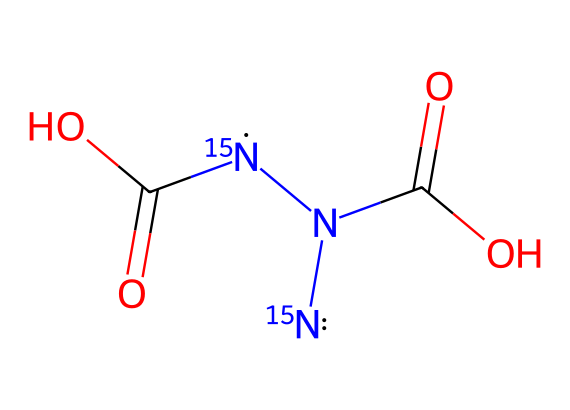How many nitrogen atoms are present in this compound? The SMILES representation indicates the presence of two [15N] nitrogen atoms, which are specifically labeled with the isotope nitrogen-15.
Answer: two What functional groups are present in this chemical structure? Analyzing the SMILES representation reveals two carboxylic acid groups (C(=O)O) attached to the central carbon and the nitrogen atoms.
Answer: carboxylic acid What is the total number of oxygen atoms in the structure? By examining the chemical representation, there are two oxygen atoms from each of the two carboxylic acid groups, leading to a total of four oxygen atoms in the compound.
Answer: four What type of nitrogen isotope is represented in this structure? The representation shows [15N], indicating that the nitrogen in this molecular structure is the nitrogen-15 isotope, which differs from the more common nitrogen-14.
Answer: nitrogen-15 How does the presence of nitrogen-15 affect the compound's use in food preservation packaging? Nitrogen-15, being an isotope, can provide useful tracking features in studies related to the compound's interaction with food products, potentially increasing the efficiency of its application in preserving food.
Answer: tracking What is the molecular formula for this compound? By considering the sum of atoms represented in the SMILES: 2 Nitrogen, 2 Carbons, 4 Oxygens, we formulate the molecular formula as C2H2N2O4, with implicit hydrogen atoms accounted for.
Answer: C2H2N2O4 What can you infer about the stability of compounds featuring nitrogen-15? Isotopes like nitrogen-15 can provide insights into the compound's stability as their nuclear properties can affect reaction rates and mechanisms in chemical processes involving preservation.
Answer: stability insights 